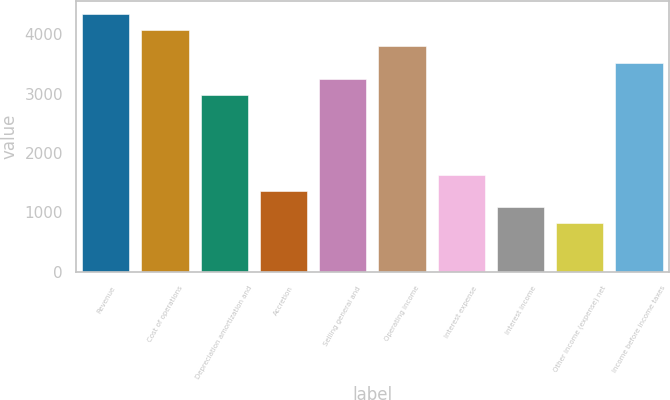<chart> <loc_0><loc_0><loc_500><loc_500><bar_chart><fcel>Revenue<fcel>Cost of operations<fcel>Depreciation amortization and<fcel>Accretion<fcel>Selling general and<fcel>Operating income<fcel>Interest expense<fcel>Interest income<fcel>Other income (expense) net<fcel>Income before income taxes<nl><fcel>4332.88<fcel>4062.09<fcel>2978.93<fcel>1354.19<fcel>3249.72<fcel>3791.3<fcel>1624.98<fcel>1083.4<fcel>812.61<fcel>3520.51<nl></chart> 